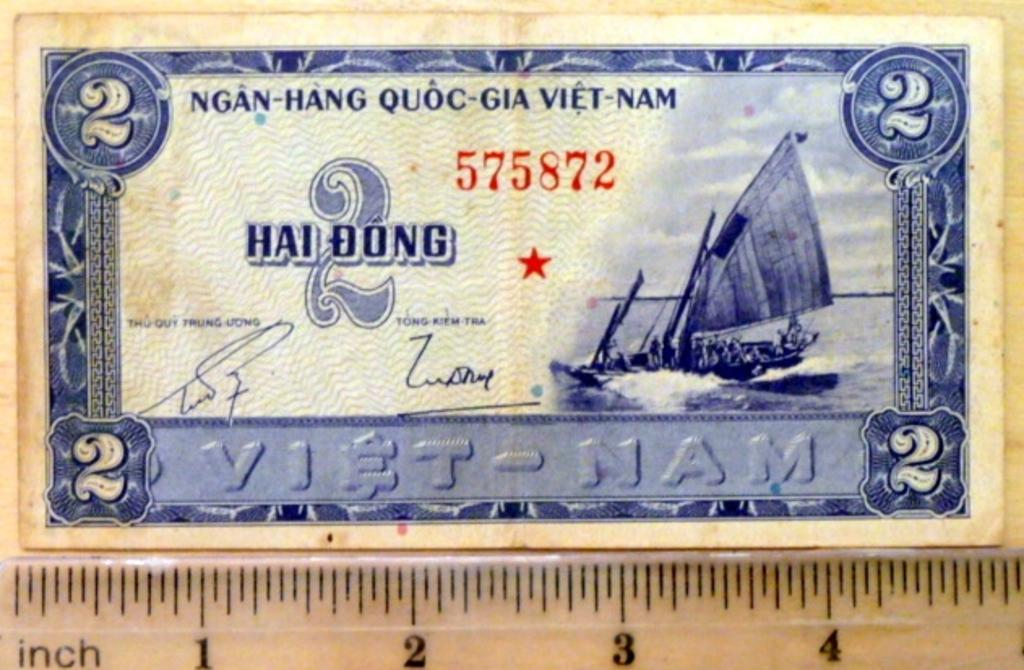What is the main object in the image? There is a currency note in the image. What is located at the bottom of the image? There is a scale at the bottom of the image. What type of bun is being weighed on the scale in the image? There is no bun present in the image; the scale is not being used to weigh any food items. 